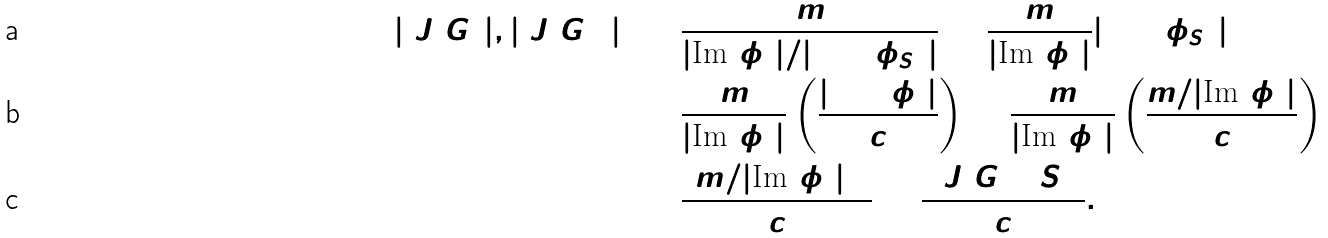Convert formula to latex. <formula><loc_0><loc_0><loc_500><loc_500>\gcd ( | \ J ( G ) | , | \ J ( G _ { 1 } ) | ) & = \frac { m } { | \text {Im} ( \phi ) | / | \ker ( \phi _ { S } ) | } = \frac { m } { | \text {Im} ( \phi ) | } | \ker ( \phi _ { S } ) | \\ & = \frac { m } { | \text {Im} ( \phi ) | } \left ( \frac { | \ker ( \phi ) | } { c } \right ) = \frac { m } { | \text {Im} ( \phi ) | } \left ( \frac { m / | \text {Im} ( \phi ) | } { c } \right ) \\ & = \frac { ( m / | \text {Im} ( \phi ) | ) ^ { 2 } } { c } = \frac { [ \ J ( G ) \colon S ] ^ { 2 } } { c } .</formula> 